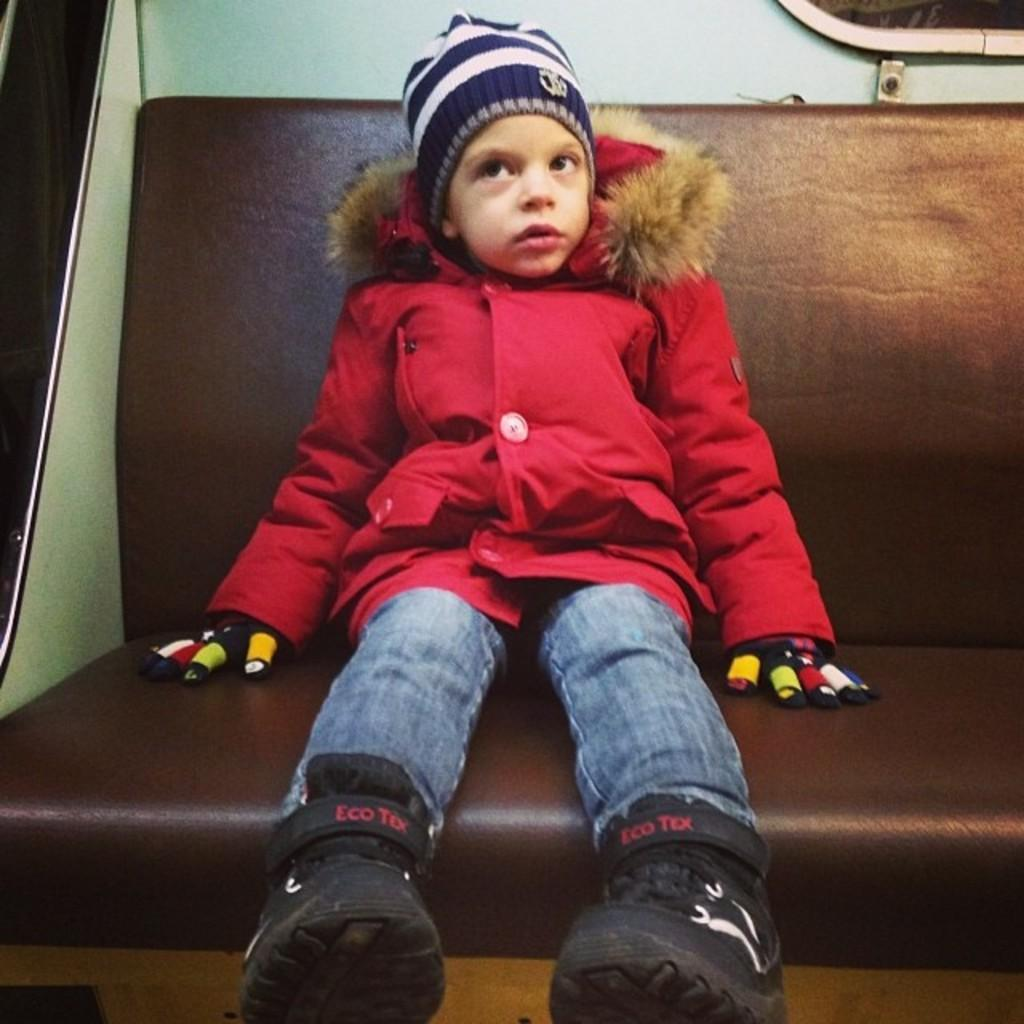What is the main subject of the image? The main subject of the image is a girl. What is the girl wearing in the image? The girl is wearing a red jacket. What piece of furniture is the girl sitting on in the image? The girl is sitting on a sofa. What thought is the girl having about her parent in the image? There is no indication in the image of the girl having any specific thoughts about her parent. 